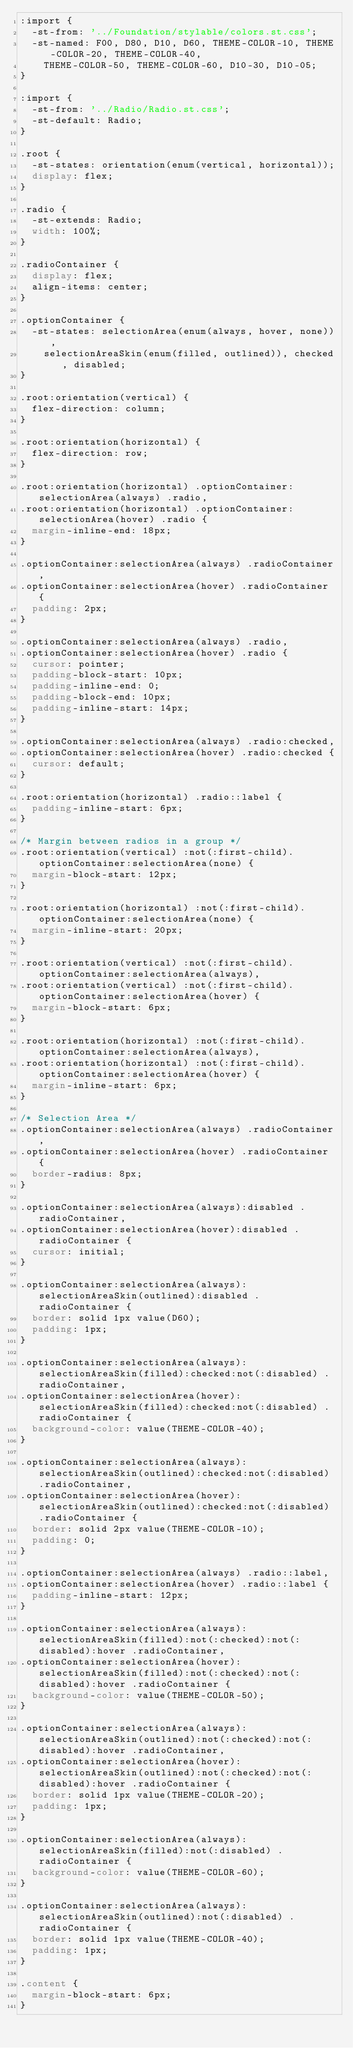<code> <loc_0><loc_0><loc_500><loc_500><_CSS_>:import {
  -st-from: '../Foundation/stylable/colors.st.css';
  -st-named: F00, D80, D10, D60, THEME-COLOR-10, THEME-COLOR-20, THEME-COLOR-40,
    THEME-COLOR-50, THEME-COLOR-60, D10-30, D10-05;
}

:import {
  -st-from: '../Radio/Radio.st.css';
  -st-default: Radio;
}

.root {
  -st-states: orientation(enum(vertical, horizontal));
  display: flex;
}

.radio {
  -st-extends: Radio;
  width: 100%;
}

.radioContainer {
  display: flex;
  align-items: center;
} 

.optionContainer {
  -st-states: selectionArea(enum(always, hover, none)), 
    selectionAreaSkin(enum(filled, outlined)), checked, disabled;
}

.root:orientation(vertical) {
  flex-direction: column;
}

.root:orientation(horizontal) {
  flex-direction: row;
}

.root:orientation(horizontal) .optionContainer:selectionArea(always) .radio,
.root:orientation(horizontal) .optionContainer:selectionArea(hover) .radio {
  margin-inline-end: 18px;
}

.optionContainer:selectionArea(always) .radioContainer,
.optionContainer:selectionArea(hover) .radioContainer {
  padding: 2px;
}

.optionContainer:selectionArea(always) .radio,
.optionContainer:selectionArea(hover) .radio {
  cursor: pointer;
  padding-block-start: 10px;
  padding-inline-end: 0;
  padding-block-end: 10px;
  padding-inline-start: 14px;
}

.optionContainer:selectionArea(always) .radio:checked,
.optionContainer:selectionArea(hover) .radio:checked {
  cursor: default;
}

.root:orientation(horizontal) .radio::label {
  padding-inline-start: 6px;
}

/* Margin between radios in a group */
.root:orientation(vertical) :not(:first-child).optionContainer:selectionArea(none) {
  margin-block-start: 12px;
}

.root:orientation(horizontal) :not(:first-child).optionContainer:selectionArea(none) {
  margin-inline-start: 20px;
}

.root:orientation(vertical) :not(:first-child).optionContainer:selectionArea(always),
.root:orientation(vertical) :not(:first-child).optionContainer:selectionArea(hover) {
  margin-block-start: 6px;
}

.root:orientation(horizontal) :not(:first-child).optionContainer:selectionArea(always),
.root:orientation(horizontal) :not(:first-child).optionContainer:selectionArea(hover) {
  margin-inline-start: 6px;
}

/* Selection Area */
.optionContainer:selectionArea(always) .radioContainer,
.optionContainer:selectionArea(hover) .radioContainer {
  border-radius: 8px;
}

.optionContainer:selectionArea(always):disabled .radioContainer,
.optionContainer:selectionArea(hover):disabled .radioContainer {
  cursor: initial;
}

.optionContainer:selectionArea(always):selectionAreaSkin(outlined):disabled .radioContainer {
  border: solid 1px value(D60);
  padding: 1px;
}

.optionContainer:selectionArea(always):selectionAreaSkin(filled):checked:not(:disabled) .radioContainer,
.optionContainer:selectionArea(hover):selectionAreaSkin(filled):checked:not(:disabled) .radioContainer {
  background-color: value(THEME-COLOR-40);
}

.optionContainer:selectionArea(always):selectionAreaSkin(outlined):checked:not(:disabled) .radioContainer,
.optionContainer:selectionArea(hover):selectionAreaSkin(outlined):checked:not(:disabled) .radioContainer {
  border: solid 2px value(THEME-COLOR-10);
  padding: 0;
}

.optionContainer:selectionArea(always) .radio::label,
.optionContainer:selectionArea(hover) .radio::label {
  padding-inline-start: 12px;
}

.optionContainer:selectionArea(always):selectionAreaSkin(filled):not(:checked):not(:disabled):hover .radioContainer,
.optionContainer:selectionArea(hover):selectionAreaSkin(filled):not(:checked):not(:disabled):hover .radioContainer {
  background-color: value(THEME-COLOR-50);
}

.optionContainer:selectionArea(always):selectionAreaSkin(outlined):not(:checked):not(:disabled):hover .radioContainer,
.optionContainer:selectionArea(hover):selectionAreaSkin(outlined):not(:checked):not(:disabled):hover .radioContainer {
  border: solid 1px value(THEME-COLOR-20);
  padding: 1px;
}

.optionContainer:selectionArea(always):selectionAreaSkin(filled):not(:disabled) .radioContainer {
  background-color: value(THEME-COLOR-60);
}

.optionContainer:selectionArea(always):selectionAreaSkin(outlined):not(:disabled) .radioContainer {
  border: solid 1px value(THEME-COLOR-40);
  padding: 1px;
}

.content {
  margin-block-start: 6px;
}
</code> 